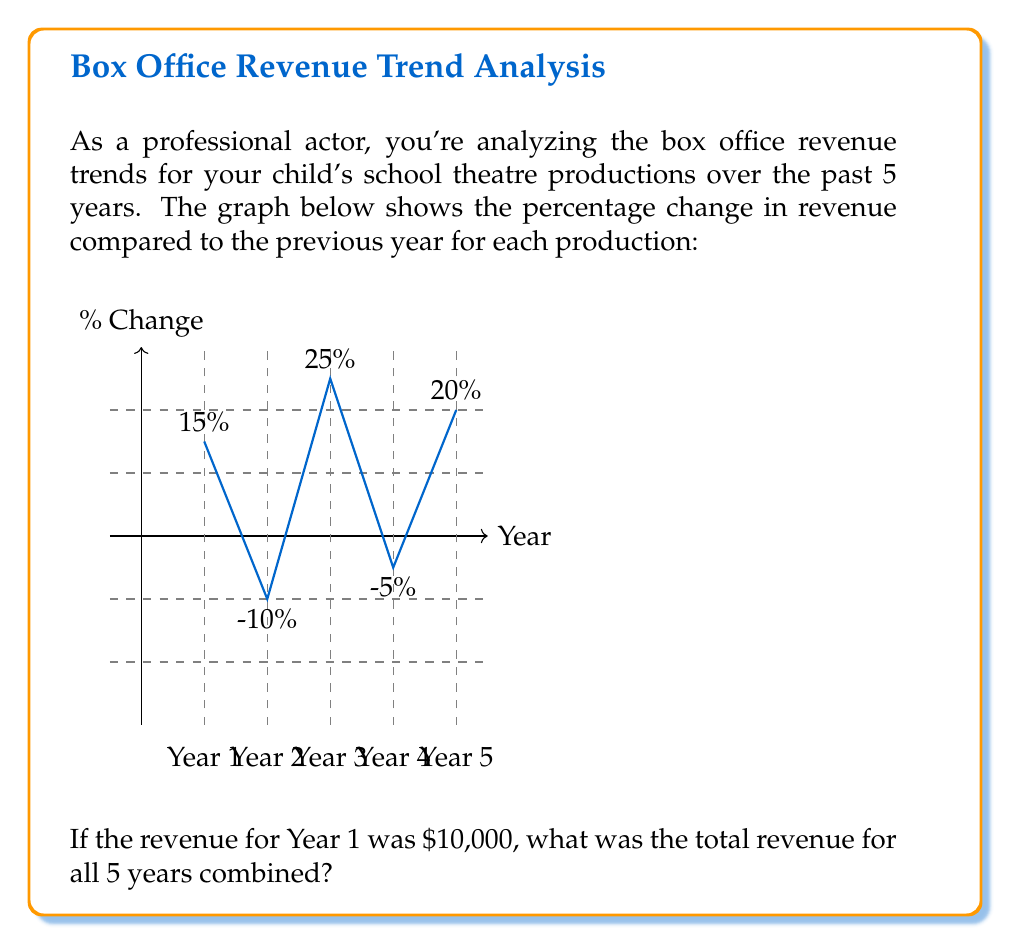Can you answer this question? Let's approach this step-by-step:

1) We know the revenue for Year 1 was $10,000.

2) For each subsequent year, we need to calculate the revenue based on the percentage change:

   Year 2: $10,000 * (1 - 0.10) = $9,000 (10% decrease)
   Year 3: $9,000 * (1 + 0.25) = $11,250 (25% increase)
   Year 4: $11,250 * (1 - 0.05) = $10,687.50 (5% decrease)
   Year 5: $10,687.50 * (1 + 0.20) = $12,825 (20% increase)

3) We can express this mathematically as:

   $$R_2 = R_1 * (1 - 0.10)$$
   $$R_3 = R_2 * (1 + 0.25)$$
   $$R_4 = R_3 * (1 - 0.05)$$
   $$R_5 = R_4 * (1 + 0.20)$$

   Where $R_n$ represents the revenue for year $n$.

4) Now, we sum up the revenues for all 5 years:

   $$\text{Total Revenue} = R_1 + R_2 + R_3 + R_4 + R_5$$
   $$= 10000 + 9000 + 11250 + 10687.50 + 12825$$
   $$= 53762.50$$

Therefore, the total revenue for all 5 years combined is $53,762.50.
Answer: $53,762.50 